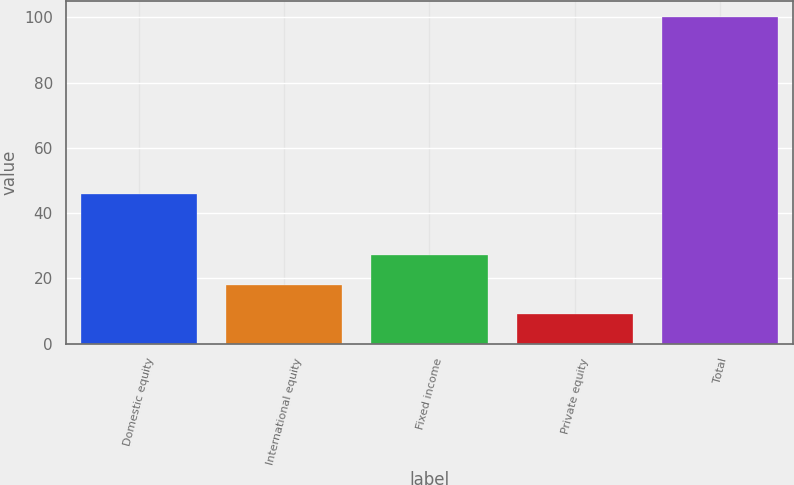Convert chart to OTSL. <chart><loc_0><loc_0><loc_500><loc_500><bar_chart><fcel>Domestic equity<fcel>International equity<fcel>Fixed income<fcel>Private equity<fcel>Total<nl><fcel>46<fcel>18.1<fcel>27.2<fcel>9<fcel>100<nl></chart> 